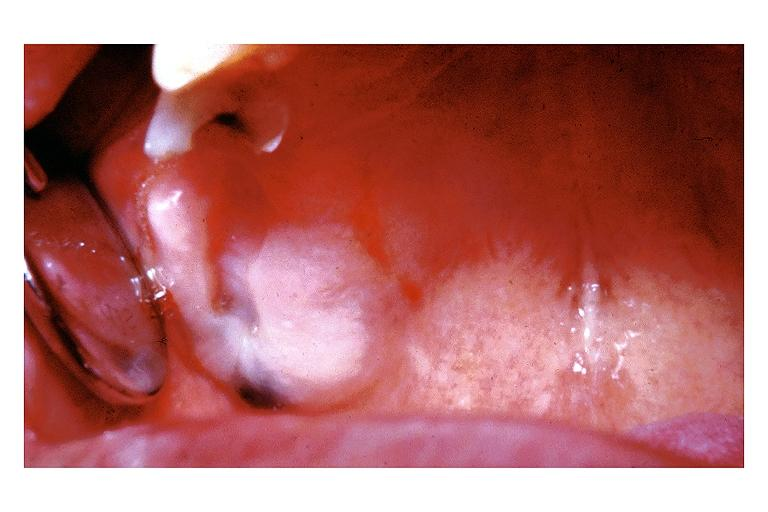what is present?
Answer the question using a single word or phrase. Oral 